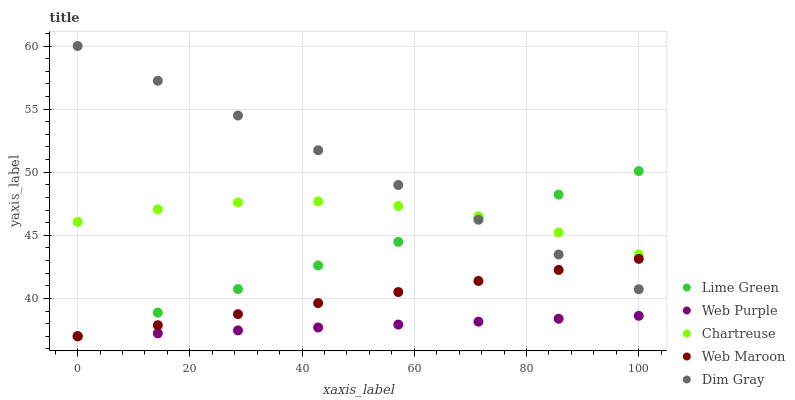Does Web Purple have the minimum area under the curve?
Answer yes or no. Yes. Does Dim Gray have the maximum area under the curve?
Answer yes or no. Yes. Does Dim Gray have the minimum area under the curve?
Answer yes or no. No. Does Web Purple have the maximum area under the curve?
Answer yes or no. No. Is Web Purple the smoothest?
Answer yes or no. Yes. Is Chartreuse the roughest?
Answer yes or no. Yes. Is Dim Gray the smoothest?
Answer yes or no. No. Is Dim Gray the roughest?
Answer yes or no. No. Does Web Maroon have the lowest value?
Answer yes or no. Yes. Does Dim Gray have the lowest value?
Answer yes or no. No. Does Dim Gray have the highest value?
Answer yes or no. Yes. Does Web Purple have the highest value?
Answer yes or no. No. Is Web Purple less than Chartreuse?
Answer yes or no. Yes. Is Chartreuse greater than Web Purple?
Answer yes or no. Yes. Does Web Purple intersect Web Maroon?
Answer yes or no. Yes. Is Web Purple less than Web Maroon?
Answer yes or no. No. Is Web Purple greater than Web Maroon?
Answer yes or no. No. Does Web Purple intersect Chartreuse?
Answer yes or no. No. 